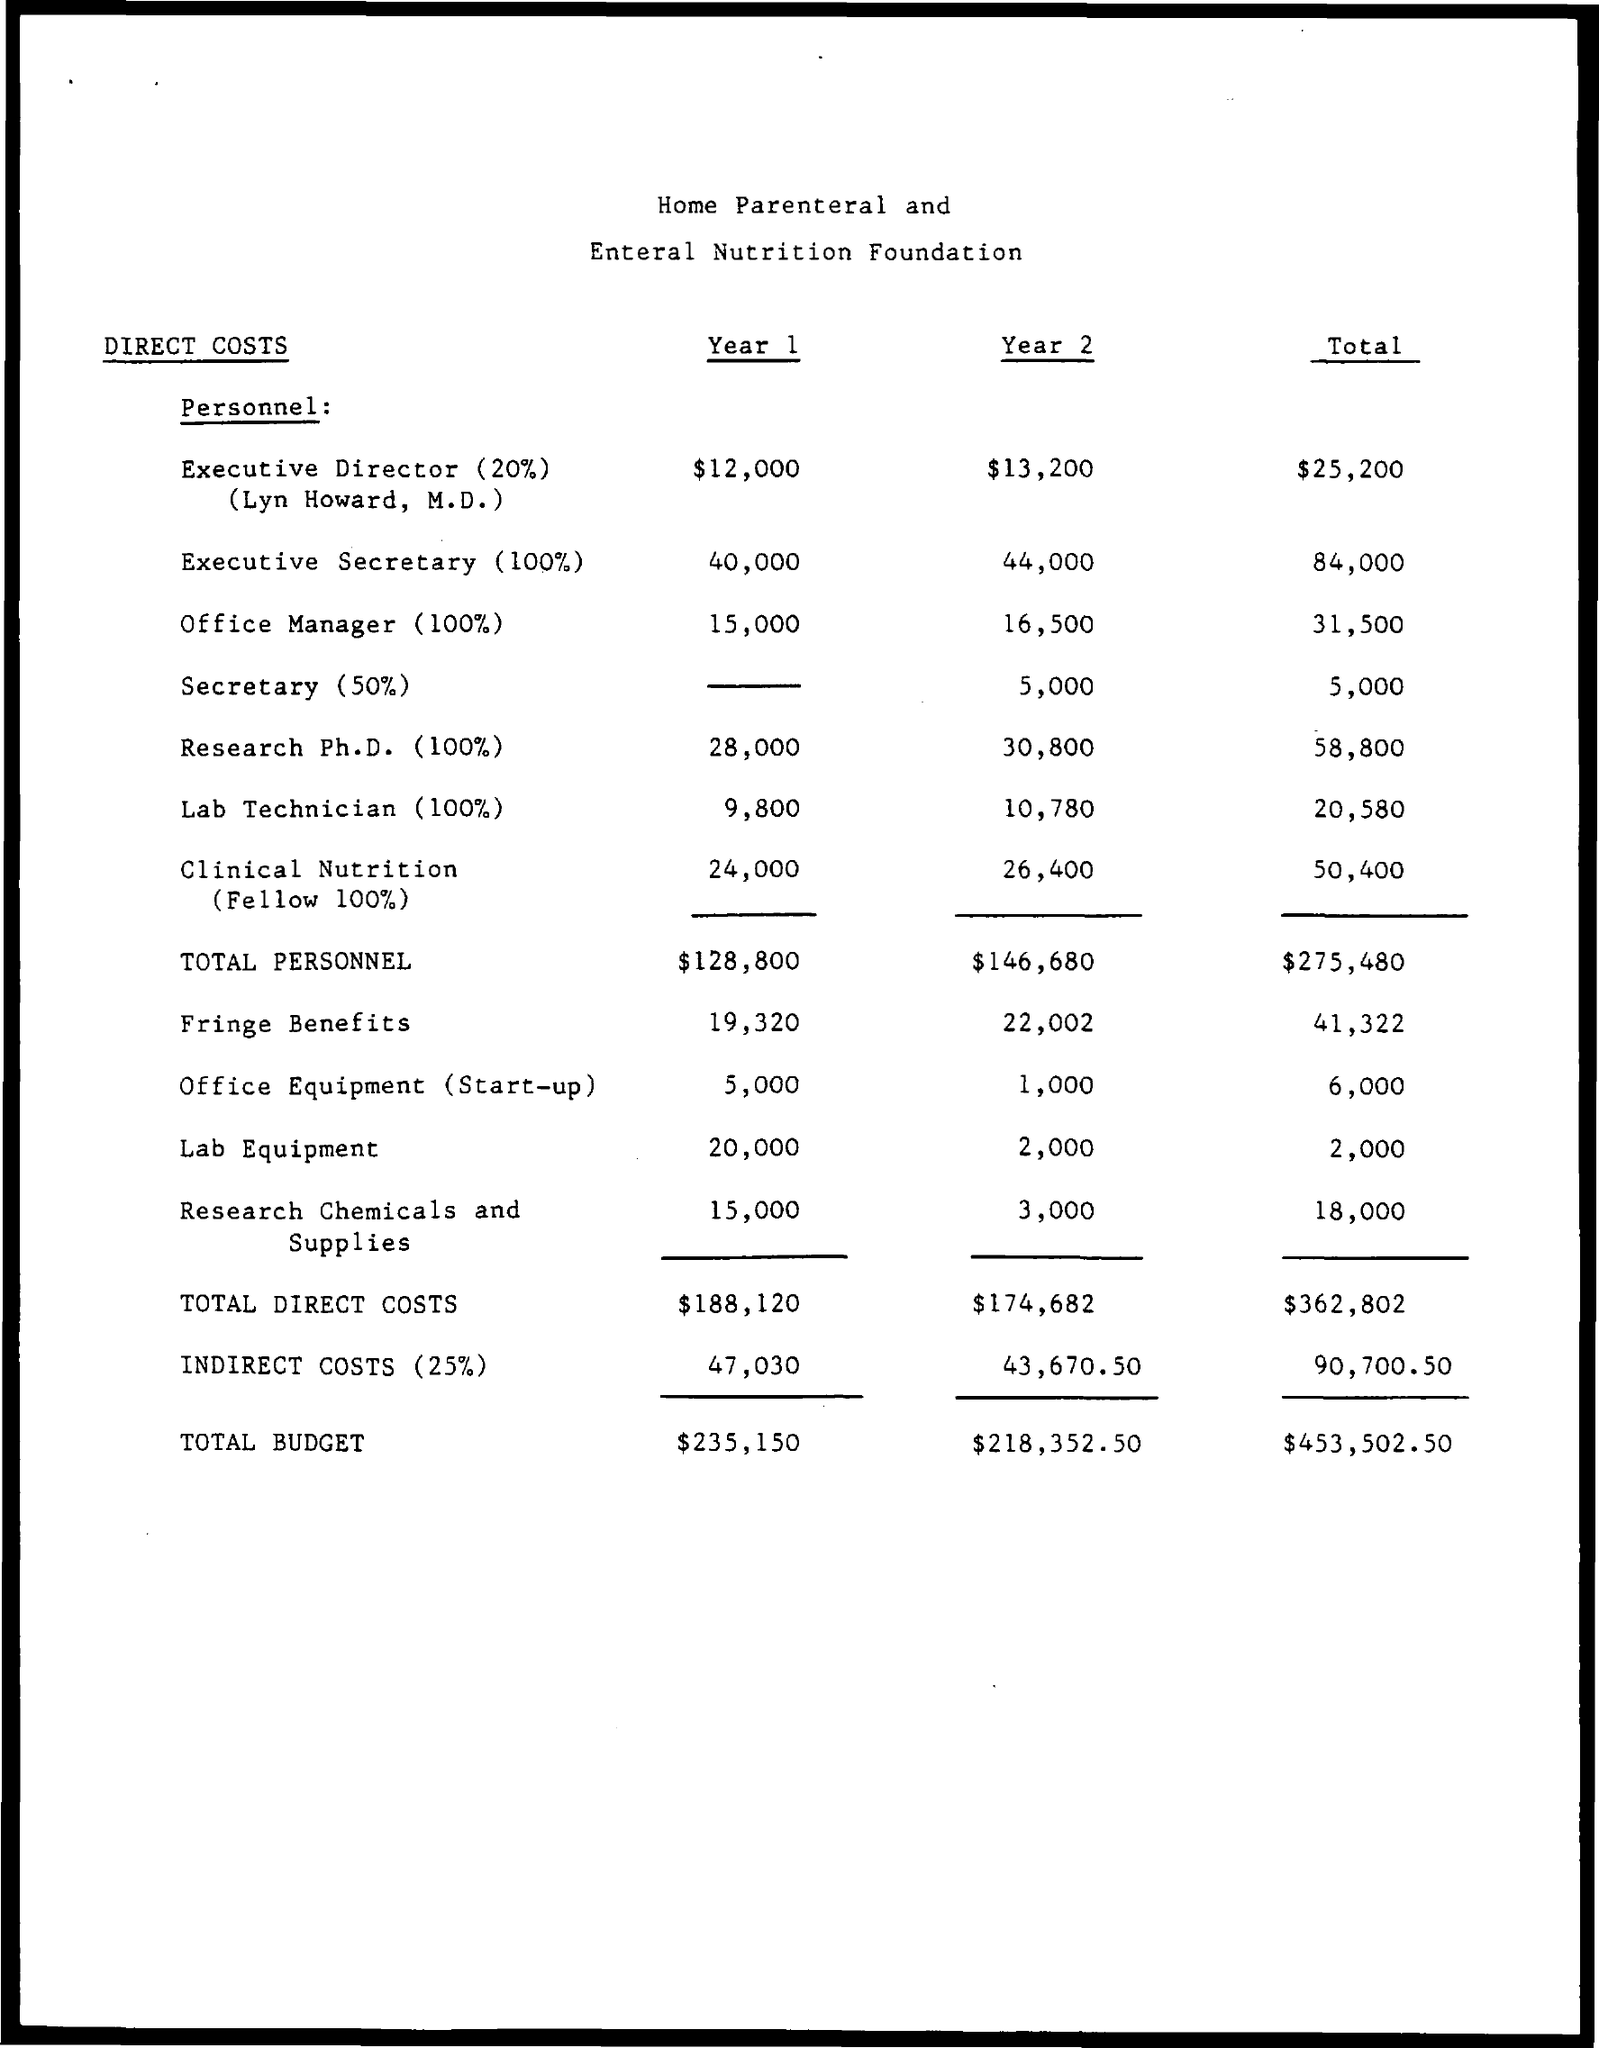Give some essential details in this illustration. The total budget in year 1 is $235,150. The total budget for year 2 is $218,352.50. The total direct costs for year 1 are $188,120. The total indirect costs for year 1, including a 25% rate, are $47,030. The indirect costs for year 2, which is 25% of the total project cost, is $43,670.50. 